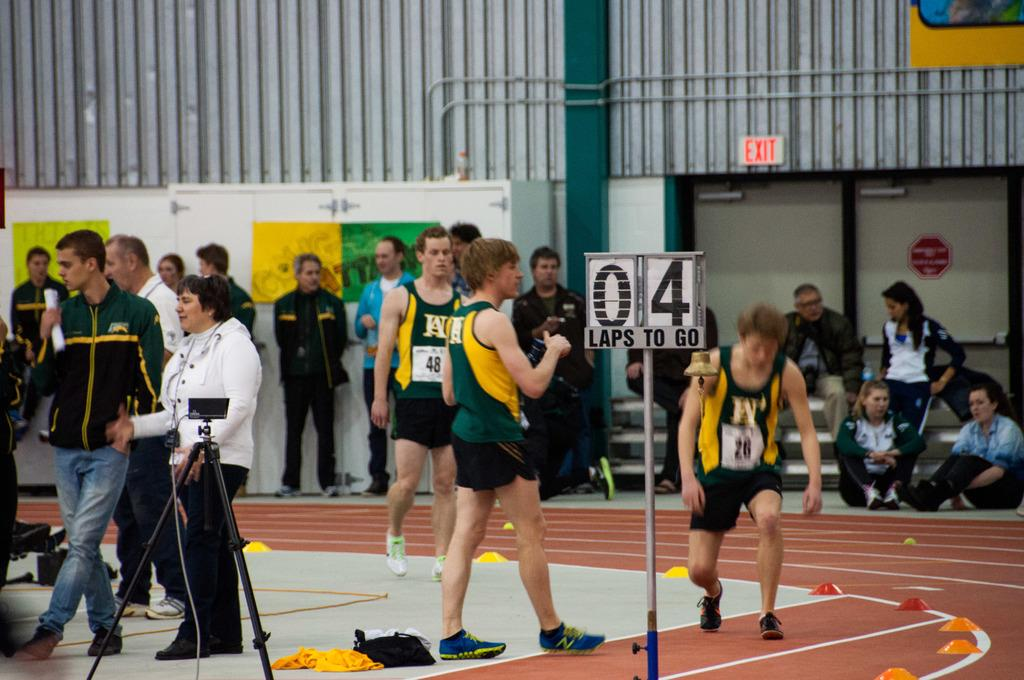<image>
Write a terse but informative summary of the picture. A sign inside of a gymnasium reads 4 laps to go 